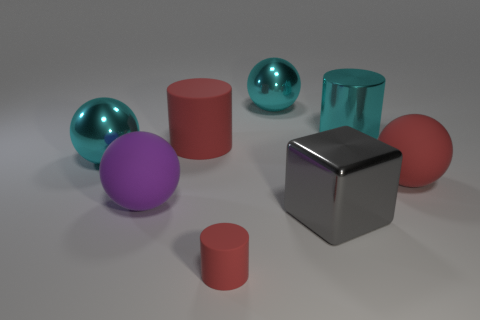Subtract 1 spheres. How many spheres are left? 3 Subtract all purple spheres. How many spheres are left? 3 Subtract all purple balls. How many balls are left? 3 Add 2 large gray cubes. How many objects exist? 10 Subtract all brown balls. Subtract all purple cylinders. How many balls are left? 4 Subtract all blocks. How many objects are left? 7 Subtract all small brown matte things. Subtract all blocks. How many objects are left? 7 Add 3 cubes. How many cubes are left? 4 Add 5 blue metallic balls. How many blue metallic balls exist? 5 Subtract 1 purple spheres. How many objects are left? 7 